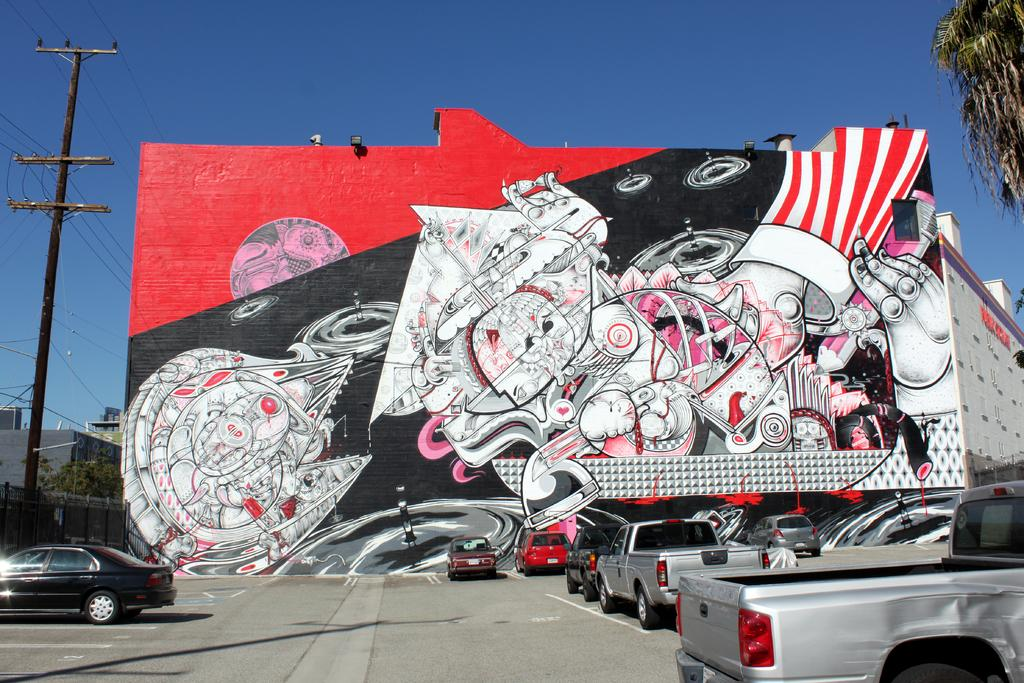What is on the wall in the image? There is graffiti on the wall in the image. What else can be seen on the wall? There are lights on the wall in the image. What type of structures are visible in the image? There are buildings in the image. What is on the road in the image? There are vehicles on the road in the image. What type of vegetation is present in the image? There are trees in the image. What is the purpose of the fence in the image? The fence in the image serves as a barrier or boundary. What can be seen in the sky in the image? The sky is visible in the image. How many friends are sitting on the corn in the image? There are no friends or corn present in the image. What type of uncle is standing near the fence in the image? There is no uncle present in the image. 